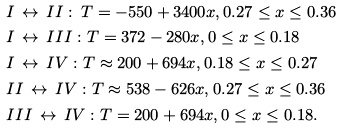Convert formula to latex. <formula><loc_0><loc_0><loc_500><loc_500>& I \, \leftrightarrow \, I I \, \colon \, T = - 5 5 0 + 3 4 0 0 x , 0 . 2 7 \leq x \leq 0 . 3 6 \\ & I \, \leftrightarrow \, I I I \, \colon T = 3 7 2 - 2 8 0 x , 0 \leq x \leq 0 . 1 8 \\ & I \, \leftrightarrow \, I V \, \colon T \approx 2 0 0 + 6 9 4 x , 0 . 1 8 \leq x \leq 0 . 2 7 \\ & I I \, \leftrightarrow \, I V \, \colon T \approx 5 3 8 - 6 2 6 x , 0 . 2 7 \leq x \leq 0 . 3 6 \\ & I I I \, \leftrightarrow \, I V \, \colon T = 2 0 0 + 6 9 4 x , 0 \leq x \leq 0 . 1 8 .</formula> 